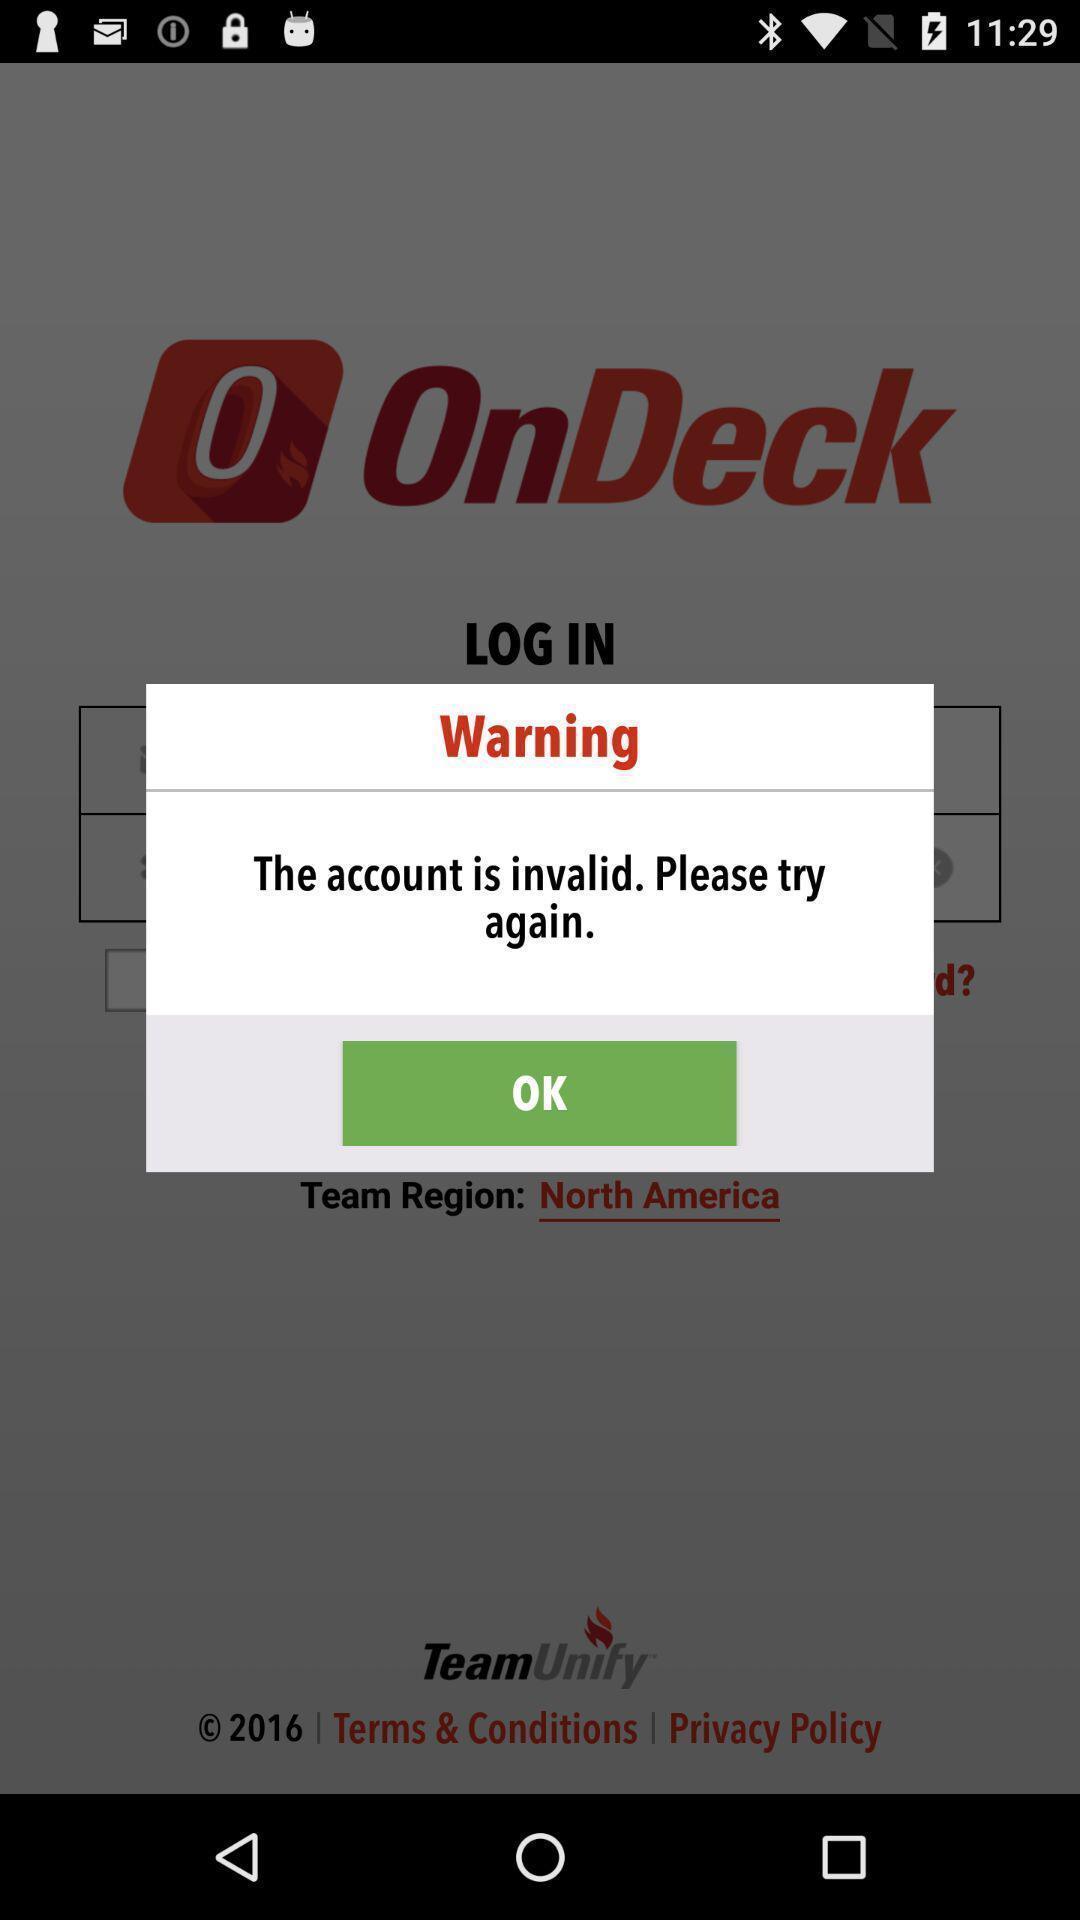Provide a description of this screenshot. Pop-up displaying a warning in application. 